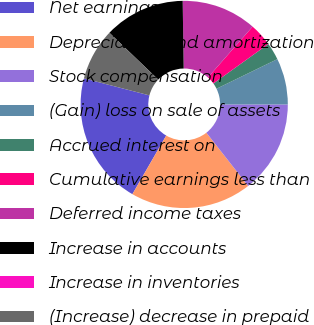Convert chart. <chart><loc_0><loc_0><loc_500><loc_500><pie_chart><fcel>Net earnings<fcel>Depreciation and amortization<fcel>Stock compensation<fcel>(Gain) loss on sale of assets<fcel>Accrued interest on<fcel>Cumulative earnings less than<fcel>Deferred income taxes<fcel>Increase in accounts<fcel>Increase in inventories<fcel>(Increase) decrease in prepaid<nl><fcel>20.72%<fcel>18.92%<fcel>14.41%<fcel>7.21%<fcel>2.71%<fcel>3.61%<fcel>11.71%<fcel>12.61%<fcel>0.0%<fcel>8.11%<nl></chart> 